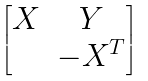<formula> <loc_0><loc_0><loc_500><loc_500>\begin{bmatrix} X & Y \\ & - X ^ { T } \end{bmatrix}</formula> 